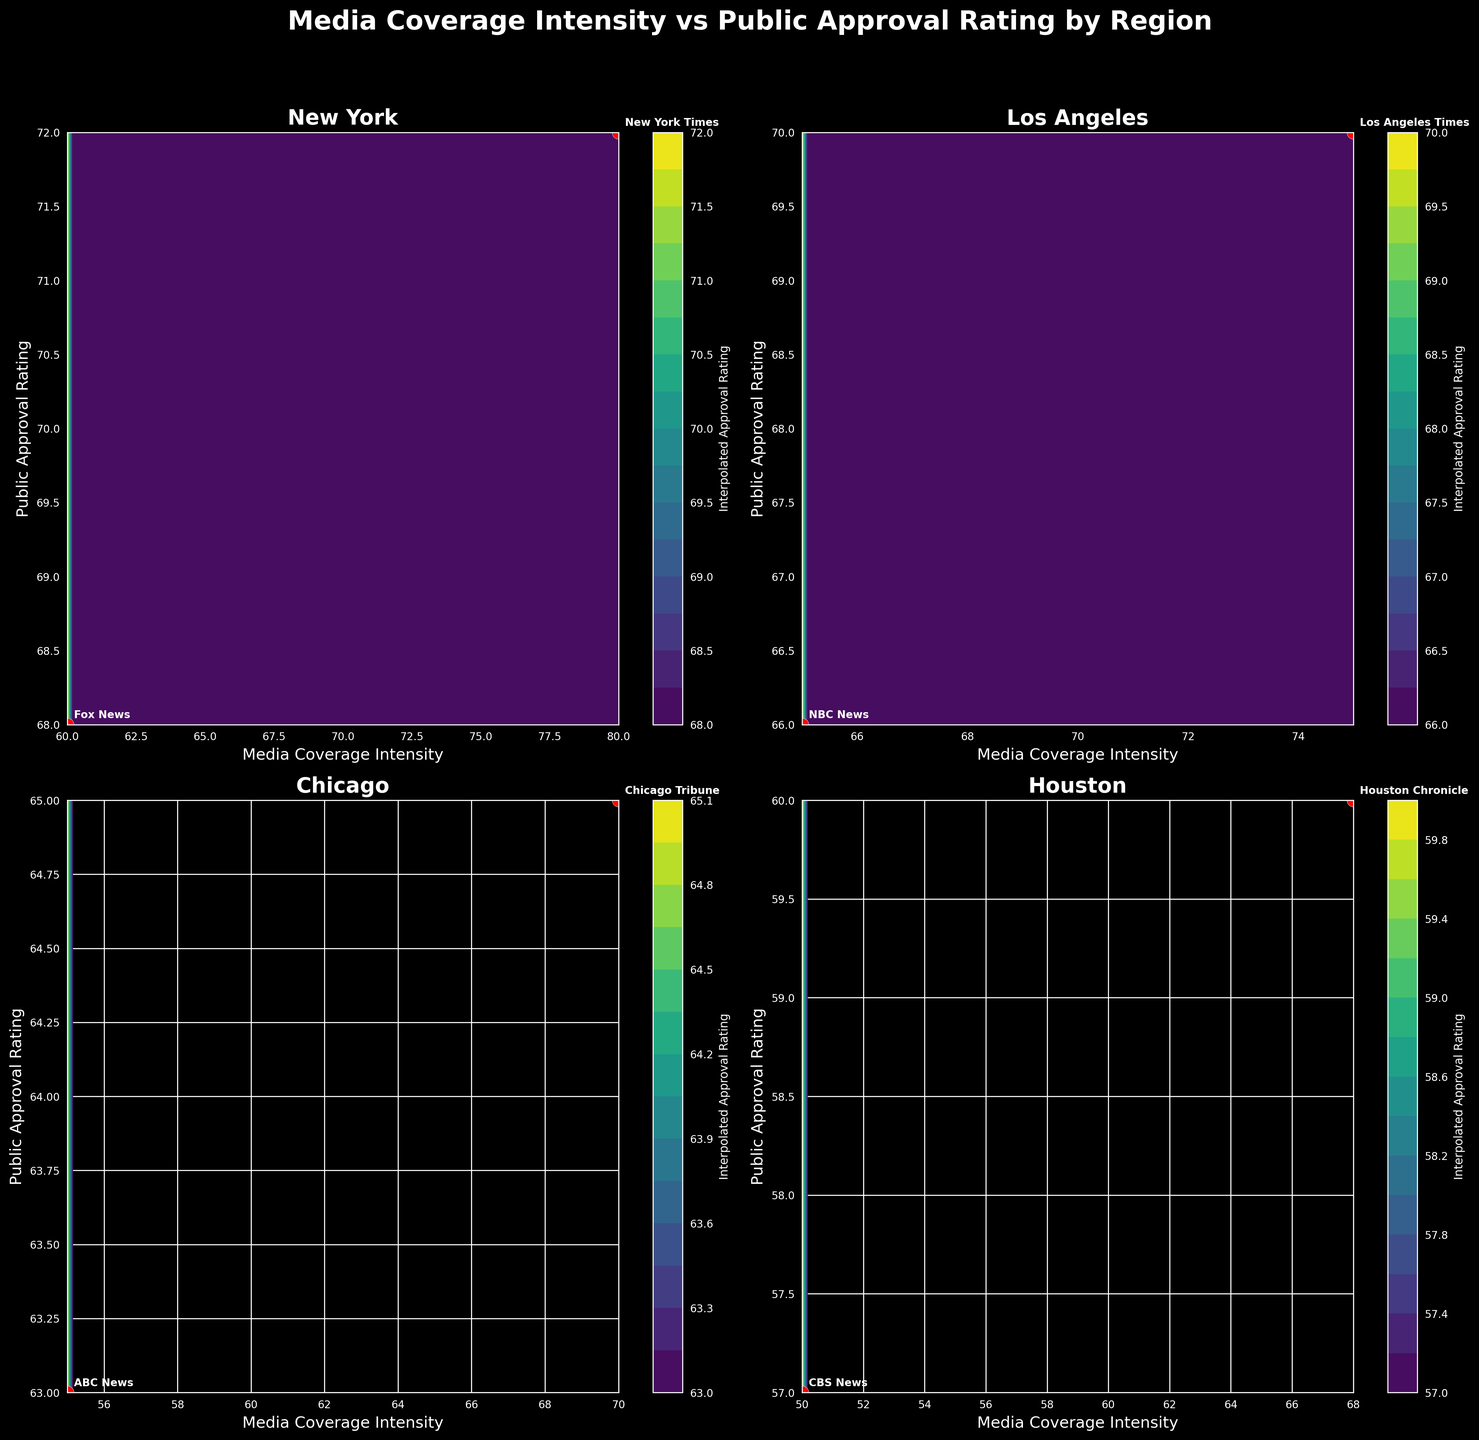What is the title of the figure? The title of the figure is written at the top of the visualization, which reads "Media Coverage Intensity vs Public Approval Rating by Region".
Answer: Media Coverage Intensity vs Public Approval Rating by Region How many subplots are there in the figure? The figure contains a grid of smaller plots, called subplots. There are two rows and two columns, making a total of 4 subplots.
Answer: 4 Which region has the highest media coverage intensity for any media outlet in the subplots? By locating the highest Media Coverage Intensity value on the x-axis across all subplots, you see that New York has the highest intensity with the New York Times at an intensity of 80.
Answer: New York Which media outlet in Los Angeles has a higher Public Approval Rating? In the Los Angeles subplot, compare the Public Approval Ratings of the Los Angeles Times and NBC News. The Los Angeles Times has a higher rating at 70 compared to NBC News at 66.
Answer: Los Angeles Times Which region shown in the subplots has the lowest approval rating for any media outlet? By comparing the lowest Public Approval Rating value in each subplot, it is clear that Houston (CBS News) has the lowest rating at 57.
Answer: Houston What is the relationship between Media Coverage Intensity and Public Approval Rating in the New York subplot? In the New York subplot, both the New York Times and Fox News have high Media Coverage Intensity and relatively high Public Approval Ratings, indicating a positive relationship.
Answer: Positive relationship Is the media coverage intensity more spread out in Chicago or Philadelphia? By observing the x-axis in the Chicago and Philadelphia subplots, Chicago's intensities range from 55 to 70, while Philadelphia's range from 55 to 70 as well. However, Philadelphia’s ratings are more clustered around 70.
Answer: Philadelphia Which region has the most varied Public Approval Ratings in its subplot? Examine the y-axis ranges in the subplots; New York ranges from 68 to 72, indicating a narrower variation, while Houston ranges from 57 to 60, indicating broader variation in approval ratings.
Answer: Houston Are any media outlets’ approval ratings significantly different from others in the same subplot for New York? In New York’s subplot, the New York Times and Fox News have similar approval ratings of 72 and 68 respectively, showing they are close to each other with no significant difference.
Answer: No significant difference 